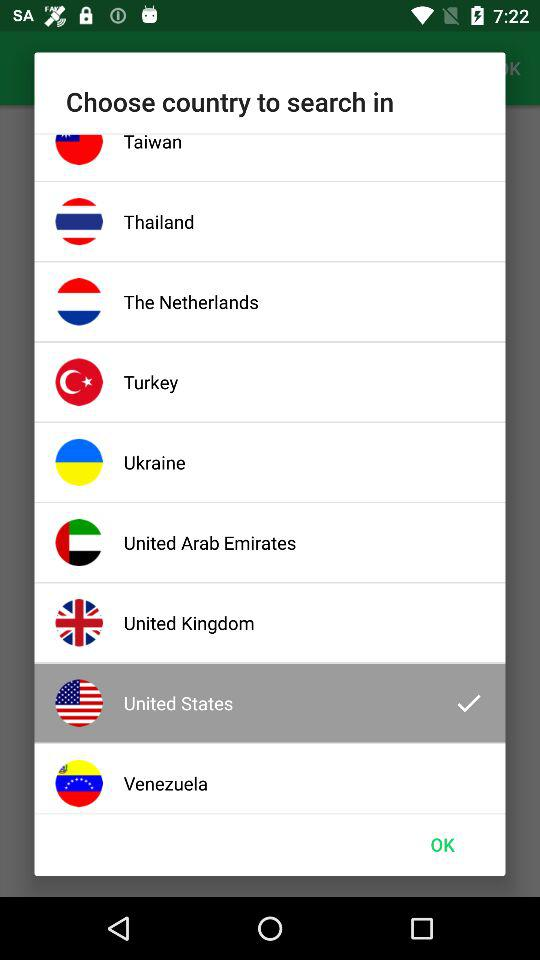Which country was chosen? The chosen country was the United States. 